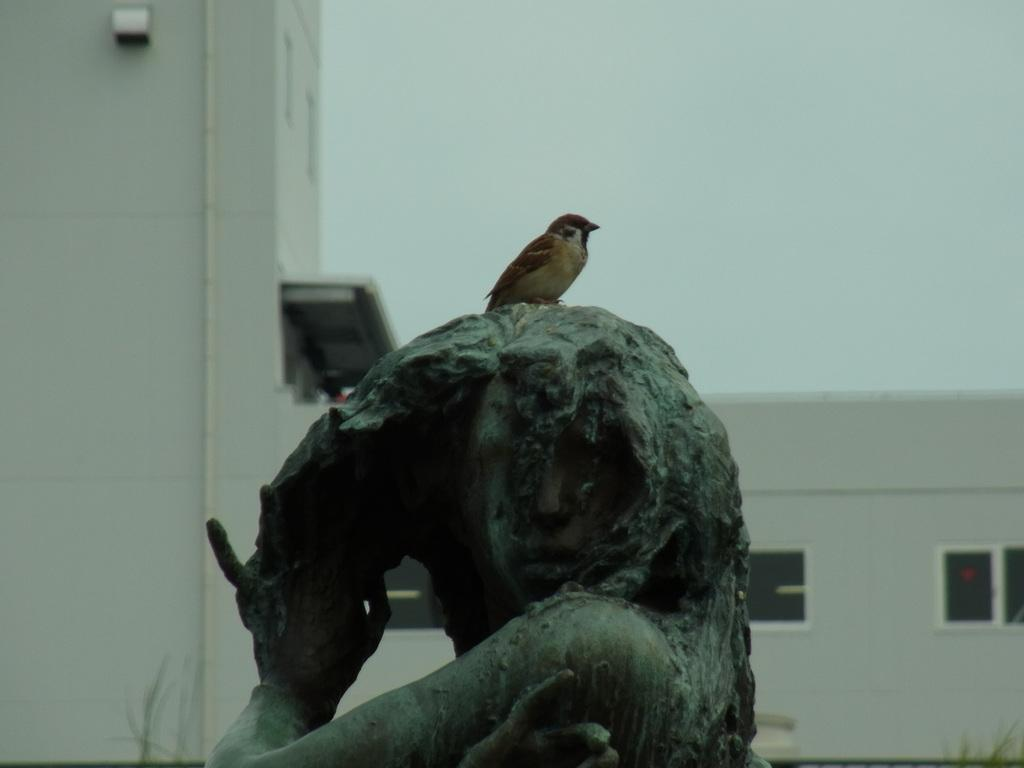What is located in the foreground of the image? There is a bird on a sculpture in the foreground of the image. What can be seen in the background of the image? There is a building and the sky visible in the background of the image. What type of celery is the bird holding in its beak in the image? There is no celery present in the image; the bird is perched on a sculpture. Can you tell me how the father in the image is interacting with the bird? There is no father present in the image; it features a bird on a sculpture and a background with a building and the sky. 